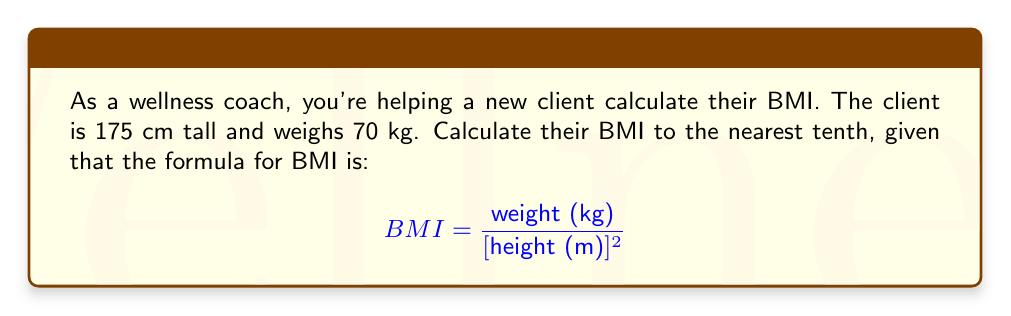Help me with this question. To calculate the BMI, we'll follow these steps:

1. Convert the height from centimeters to meters:
   $175 \text{ cm} = 1.75 \text{ m}$

2. Square the height in meters:
   $(1.75 \text{ m})^2 = 3.0625 \text{ m}^2$

3. Divide the weight by the squared height:
   $$ BMI = \frac{70 \text{ kg}}{3.0625 \text{ m}^2} = 22.857 $$

4. Round the result to the nearest tenth:
   $22.857 \approx 22.9$

Therefore, the client's BMI is 22.9 kg/m².
Answer: 22.9 kg/m² 